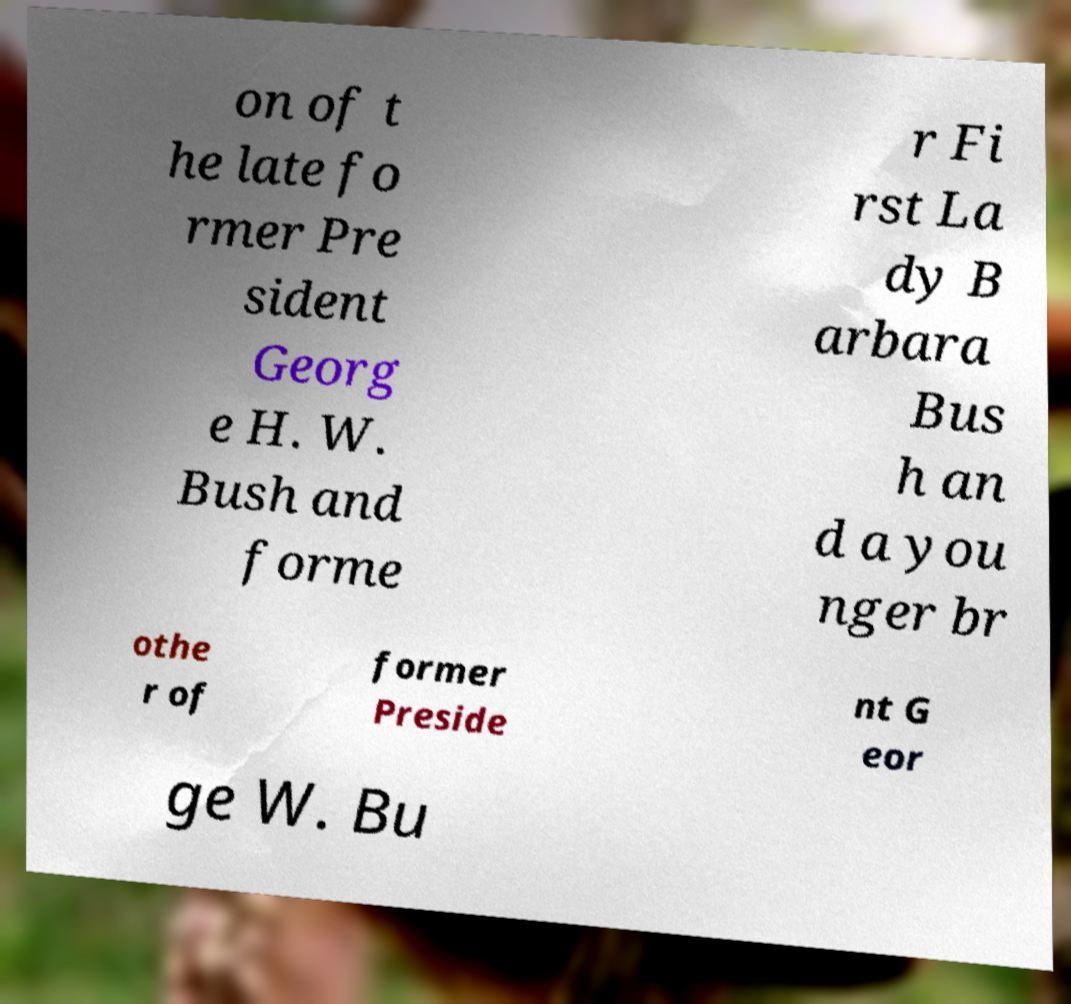Can you accurately transcribe the text from the provided image for me? on of t he late fo rmer Pre sident Georg e H. W. Bush and forme r Fi rst La dy B arbara Bus h an d a you nger br othe r of former Preside nt G eor ge W. Bu 